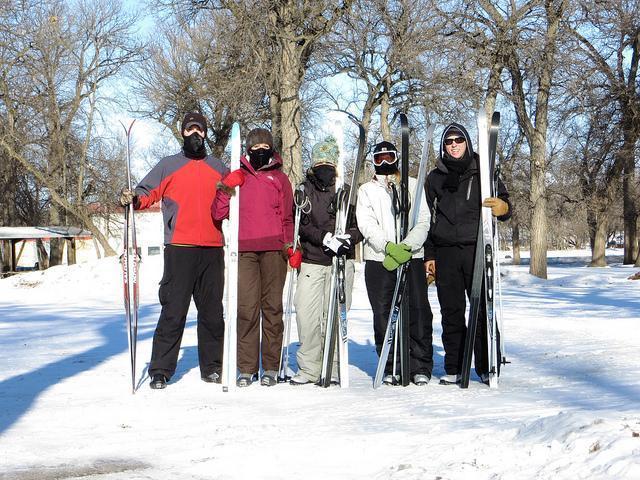How many ski can you see?
Give a very brief answer. 5. How many people are there?
Give a very brief answer. 5. 